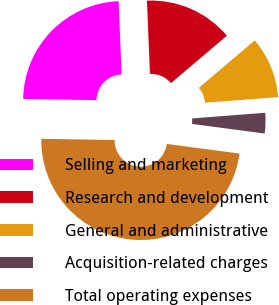Convert chart to OTSL. <chart><loc_0><loc_0><loc_500><loc_500><pie_chart><fcel>Selling and marketing<fcel>Research and development<fcel>General and administrative<fcel>Acquisition-related charges<fcel>Total operating expenses<nl><fcel>24.08%<fcel>14.45%<fcel>9.97%<fcel>3.33%<fcel>48.17%<nl></chart> 